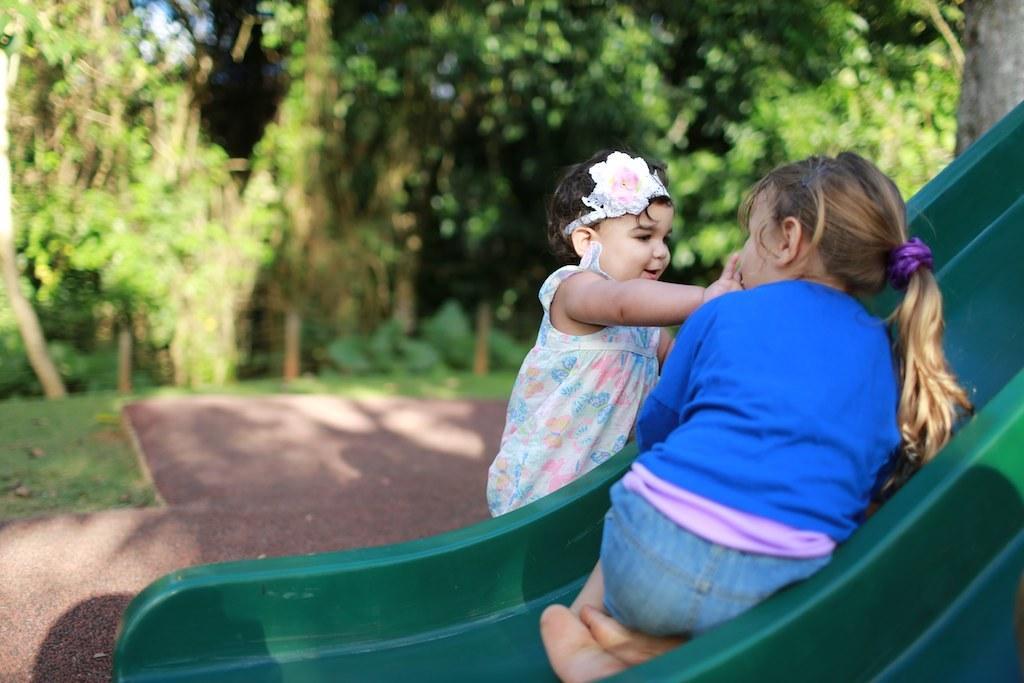How would you summarize this image in a sentence or two? In this image we can see two girls and one among them is sitting on the slide and in the background, we can see some trees. 